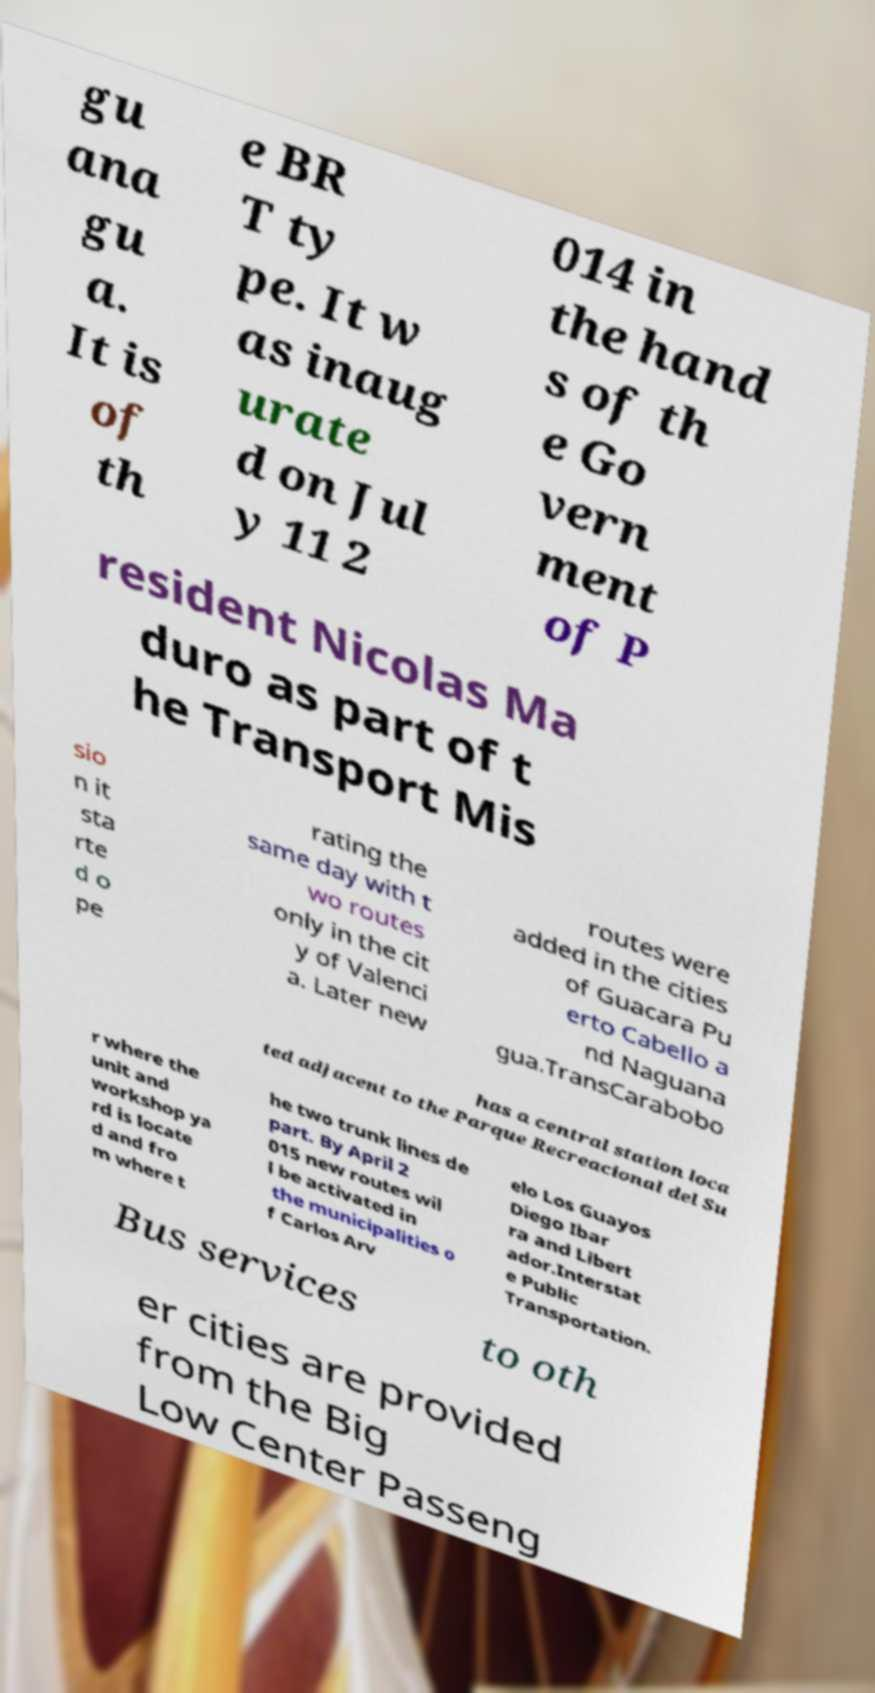Please identify and transcribe the text found in this image. gu ana gu a. It is of th e BR T ty pe. It w as inaug urate d on Jul y 11 2 014 in the hand s of th e Go vern ment of P resident Nicolas Ma duro as part of t he Transport Mis sio n it sta rte d o pe rating the same day with t wo routes only in the cit y of Valenci a. Later new routes were added in the cities of Guacara Pu erto Cabello a nd Naguana gua.TransCarabobo has a central station loca ted adjacent to the Parque Recreacional del Su r where the unit and workshop ya rd is locate d and fro m where t he two trunk lines de part. By April 2 015 new routes wil l be activated in the municipalities o f Carlos Arv elo Los Guayos Diego Ibar ra and Libert ador.Interstat e Public Transportation. Bus services to oth er cities are provided from the Big Low Center Passeng 